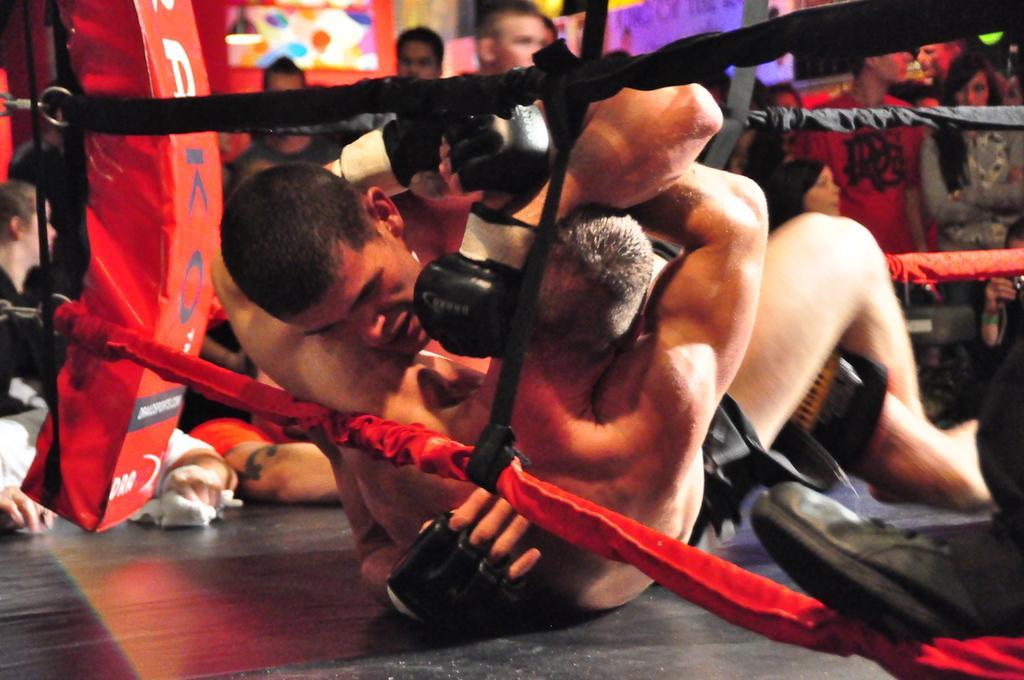Please provide a concise description of this image. In this picture we can see a group of people where some are standing and two are on boxing ring and in the background we can see the lights. 